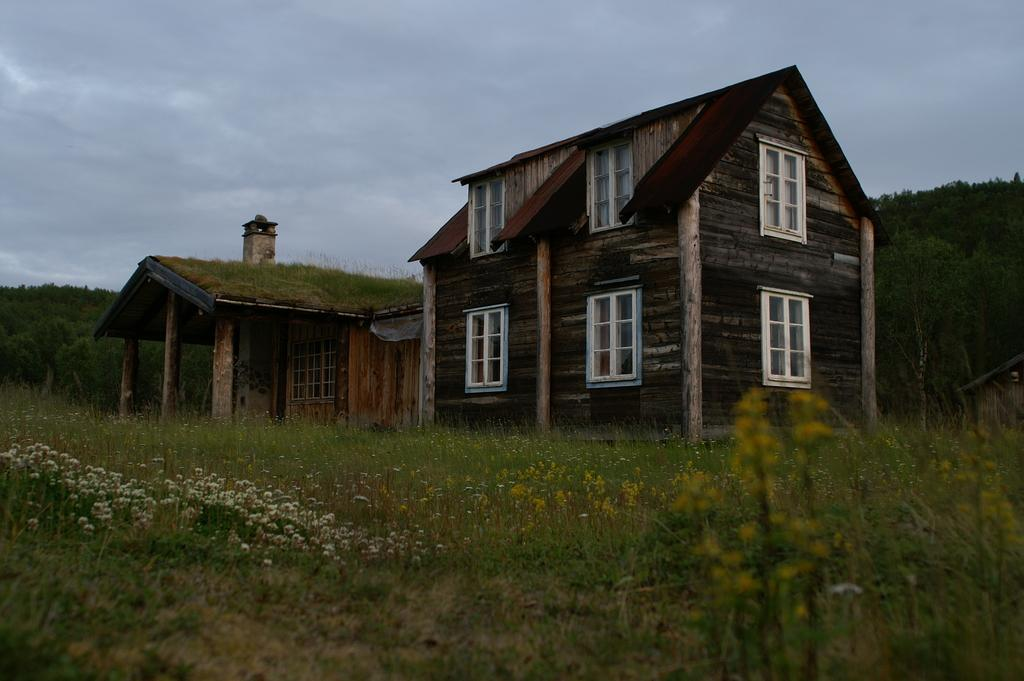What type of houses are in the image? There are wooden houses in the image. What can be seen around the houses? There is greeneryery around the houses, including trees and plants. What is visible in the sky in the image? The sky is visible in the image. What color is the silver chair in the image? There is no silver chair present in the image. 